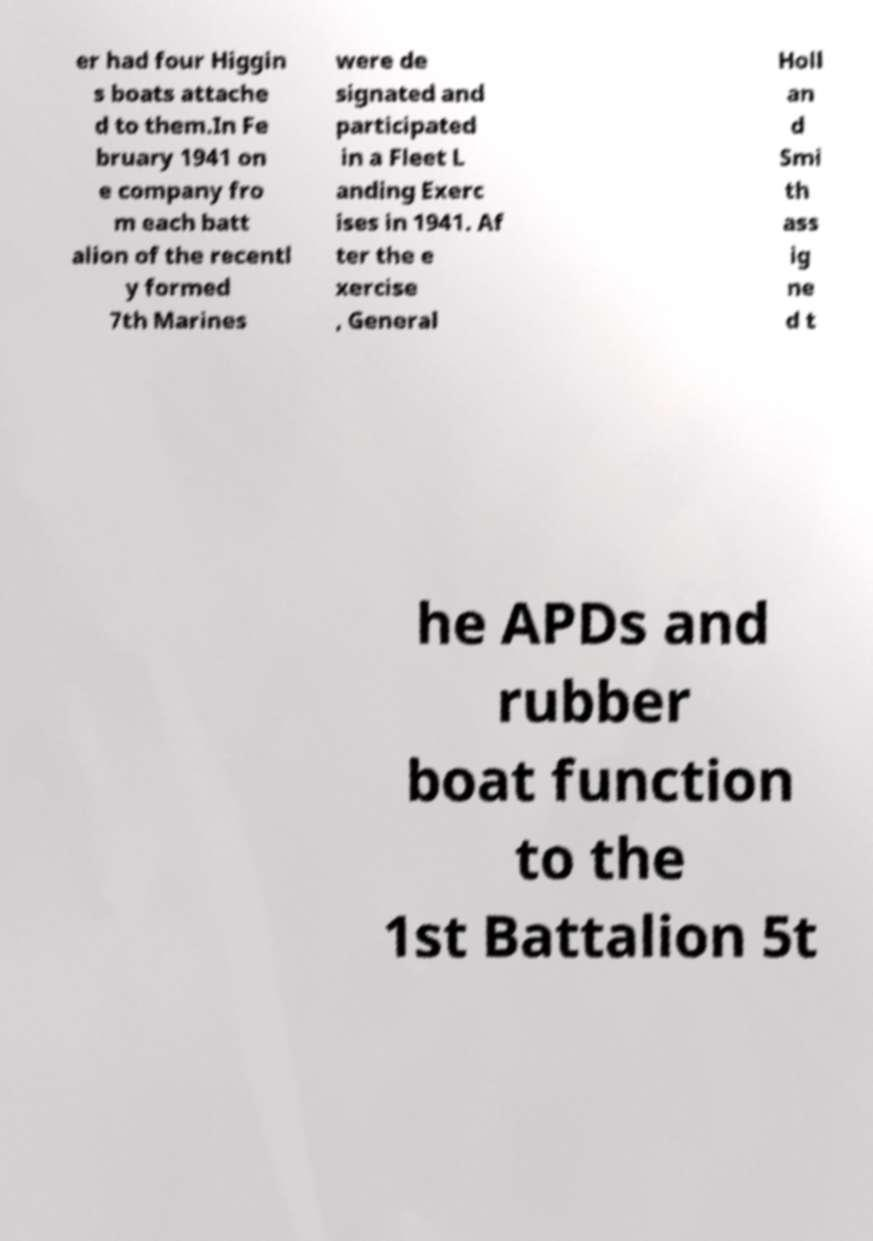I need the written content from this picture converted into text. Can you do that? er had four Higgin s boats attache d to them.In Fe bruary 1941 on e company fro m each batt alion of the recentl y formed 7th Marines were de signated and participated in a Fleet L anding Exerc ises in 1941. Af ter the e xercise , General Holl an d Smi th ass ig ne d t he APDs and rubber boat function to the 1st Battalion 5t 